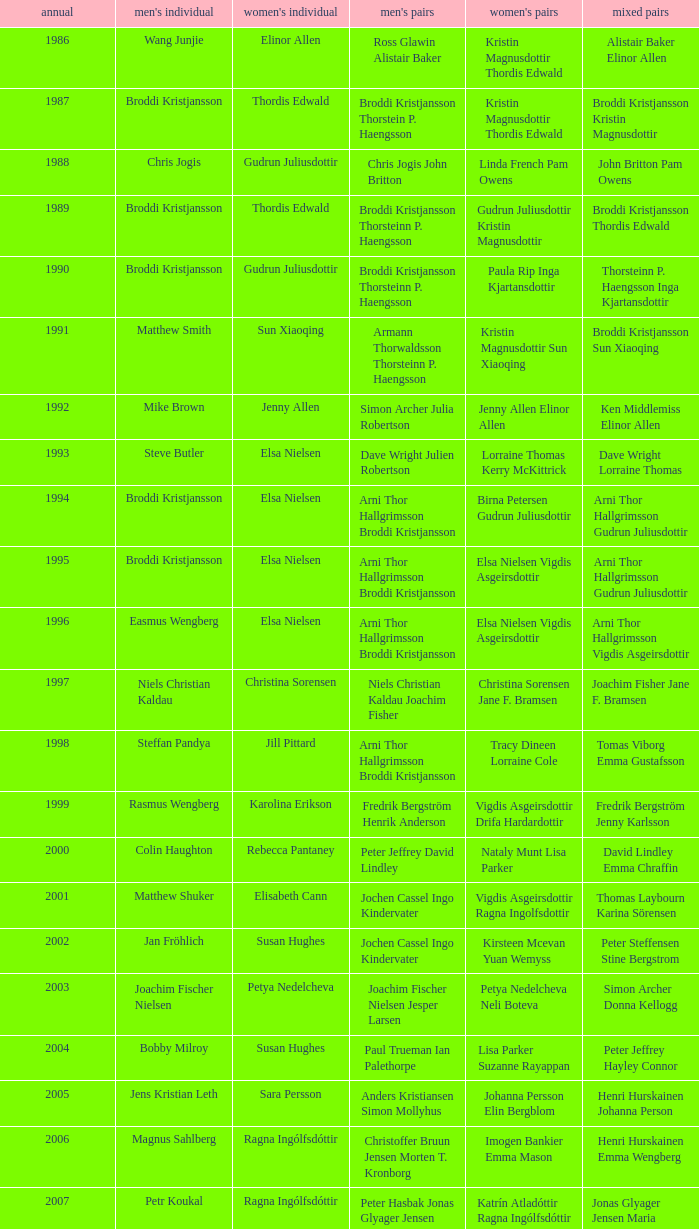In what mixed doubles did Niels Christian Kaldau play in men's singles? Joachim Fisher Jane F. Bramsen. 